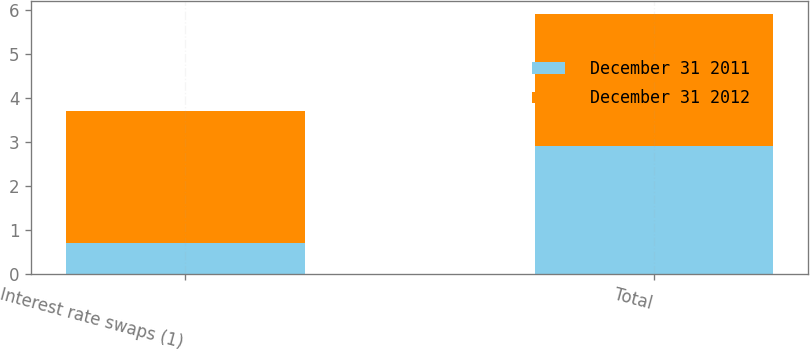Convert chart to OTSL. <chart><loc_0><loc_0><loc_500><loc_500><stacked_bar_chart><ecel><fcel>Interest rate swaps (1)<fcel>Total<nl><fcel>December 31 2011<fcel>0.7<fcel>2.9<nl><fcel>December 31 2012<fcel>3<fcel>3<nl></chart> 